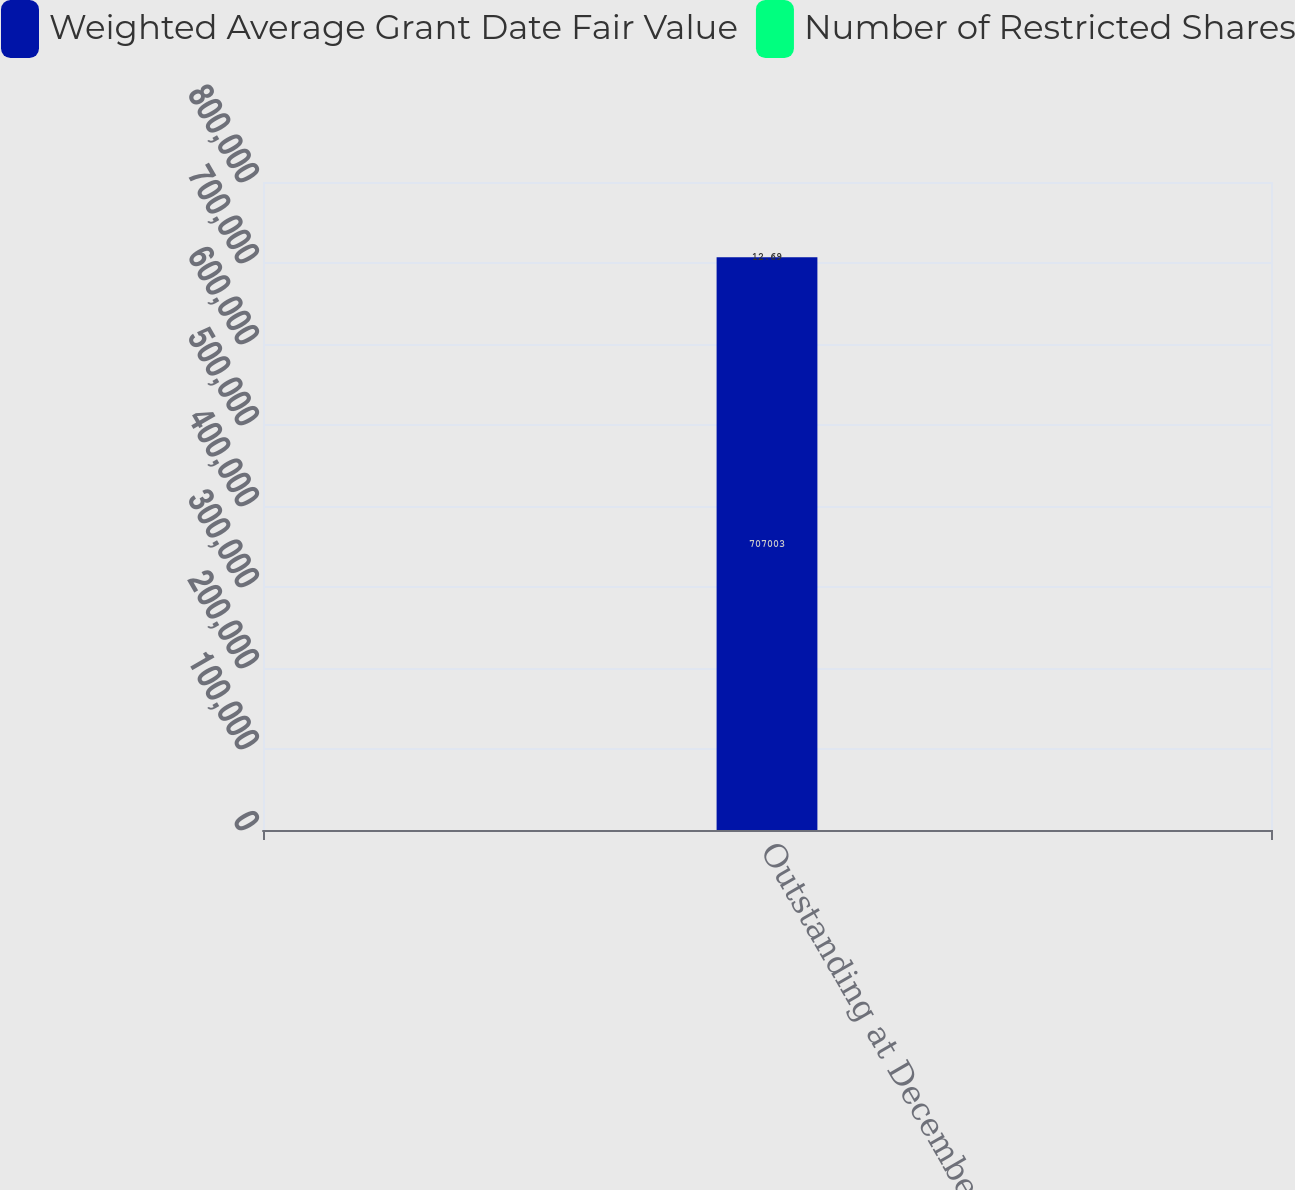Convert chart to OTSL. <chart><loc_0><loc_0><loc_500><loc_500><stacked_bar_chart><ecel><fcel>Outstanding at December 31<nl><fcel>Weighted Average Grant Date Fair Value<fcel>707003<nl><fcel>Number of Restricted Shares<fcel>12.69<nl></chart> 